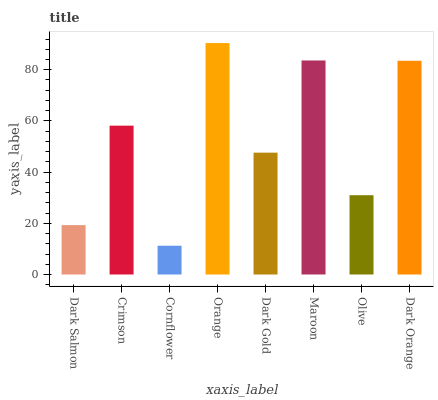Is Cornflower the minimum?
Answer yes or no. Yes. Is Orange the maximum?
Answer yes or no. Yes. Is Crimson the minimum?
Answer yes or no. No. Is Crimson the maximum?
Answer yes or no. No. Is Crimson greater than Dark Salmon?
Answer yes or no. Yes. Is Dark Salmon less than Crimson?
Answer yes or no. Yes. Is Dark Salmon greater than Crimson?
Answer yes or no. No. Is Crimson less than Dark Salmon?
Answer yes or no. No. Is Crimson the high median?
Answer yes or no. Yes. Is Dark Gold the low median?
Answer yes or no. Yes. Is Dark Gold the high median?
Answer yes or no. No. Is Orange the low median?
Answer yes or no. No. 